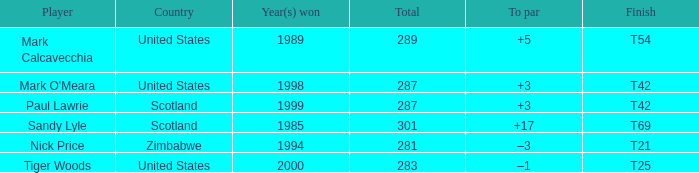What is the to par when the year(s) won is larger than 1999? –1. 